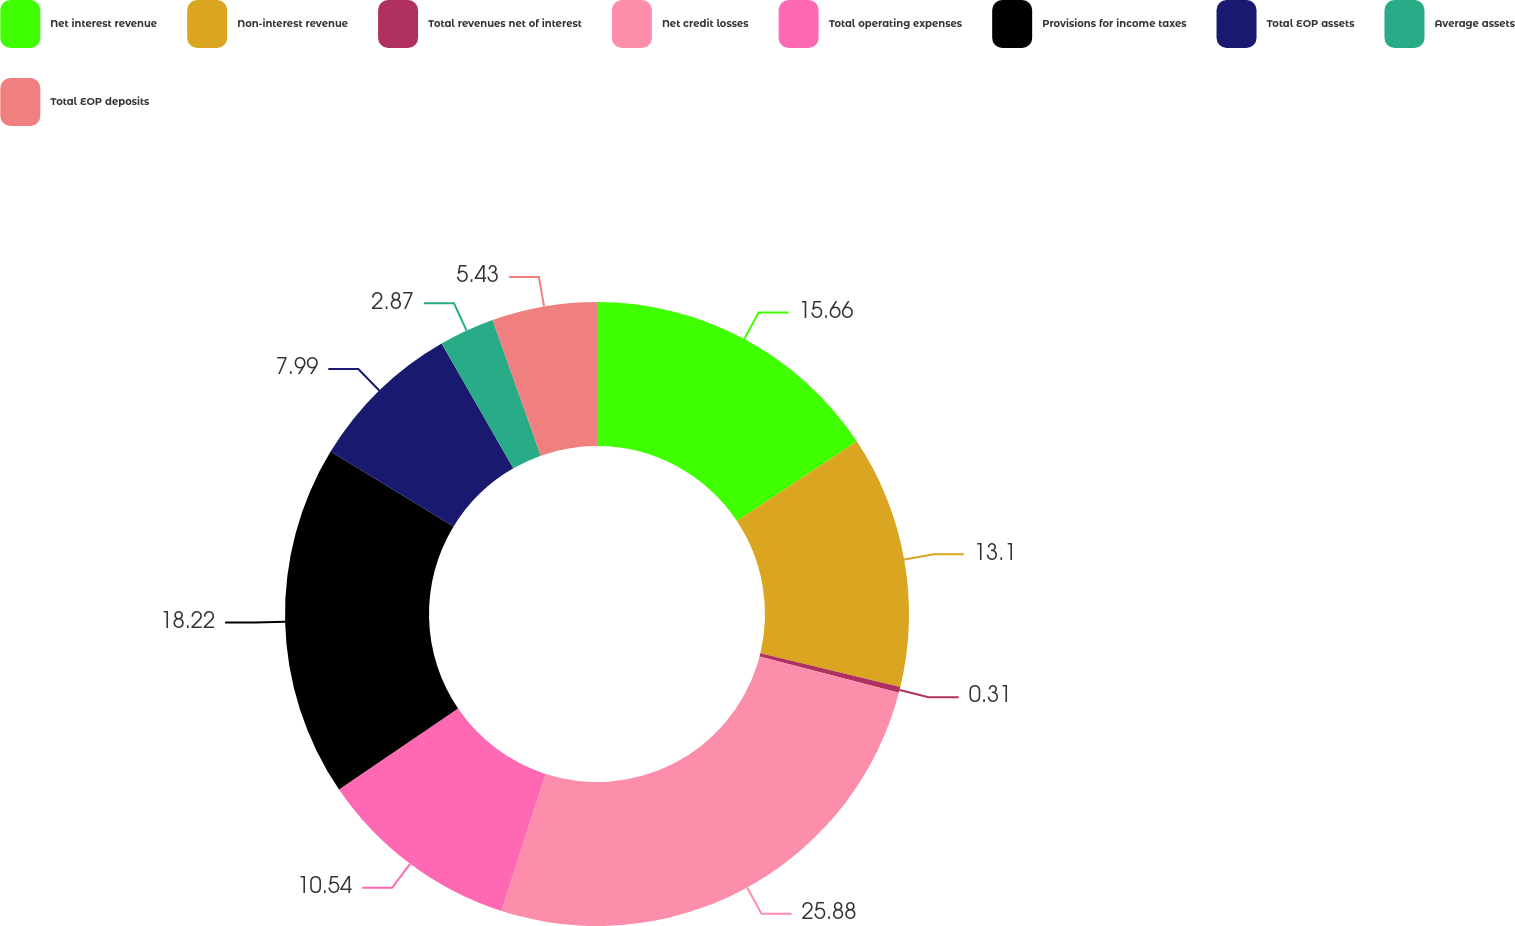<chart> <loc_0><loc_0><loc_500><loc_500><pie_chart><fcel>Net interest revenue<fcel>Non-interest revenue<fcel>Total revenues net of interest<fcel>Net credit losses<fcel>Total operating expenses<fcel>Provisions for income taxes<fcel>Total EOP assets<fcel>Average assets<fcel>Total EOP deposits<nl><fcel>15.66%<fcel>13.1%<fcel>0.31%<fcel>25.89%<fcel>10.54%<fcel>18.22%<fcel>7.99%<fcel>2.87%<fcel>5.43%<nl></chart> 